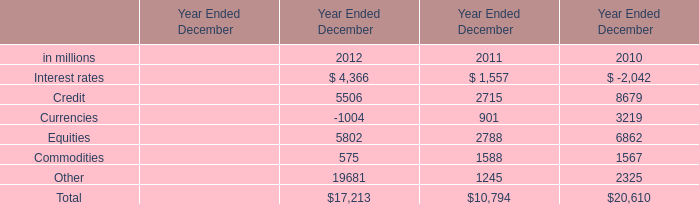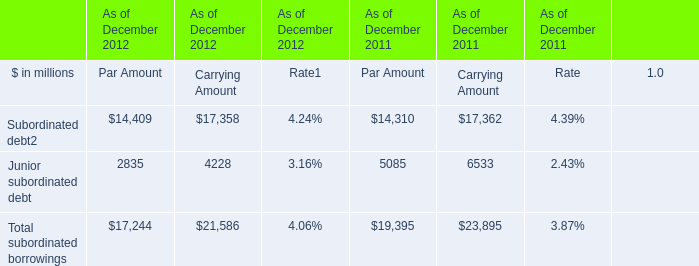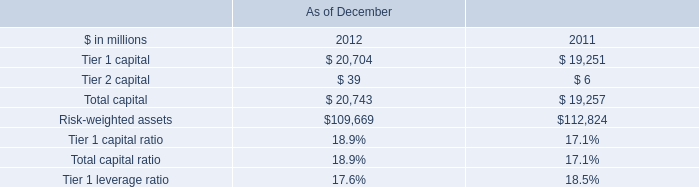What is the sum of Commodities of Year Ended December 2011, and Subordinated debt of As of December 2012 Par Amount ? 
Computations: (1588.0 + 14409.0)
Answer: 15997.0. 